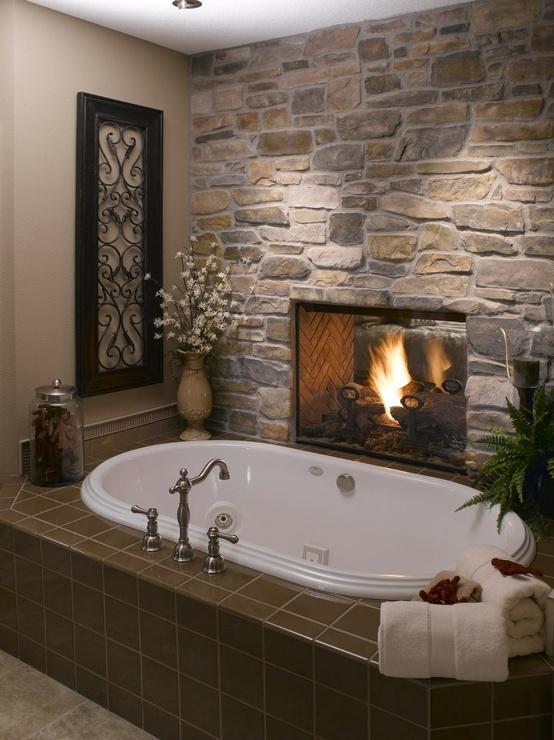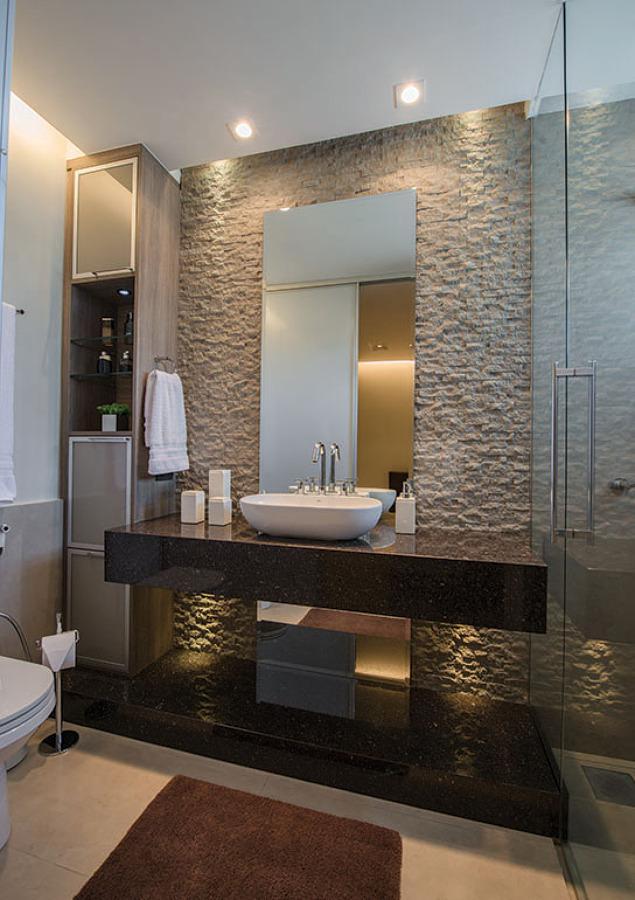The first image is the image on the left, the second image is the image on the right. Examine the images to the left and right. Is the description "One image features a bathtub, and the other shows a vessel sink atop a counter with an open space and shelf beneath it." accurate? Answer yes or no. Yes. The first image is the image on the left, the second image is the image on the right. Assess this claim about the two images: "One of the images contains a soft bath mat on the floor.". Correct or not? Answer yes or no. Yes. 